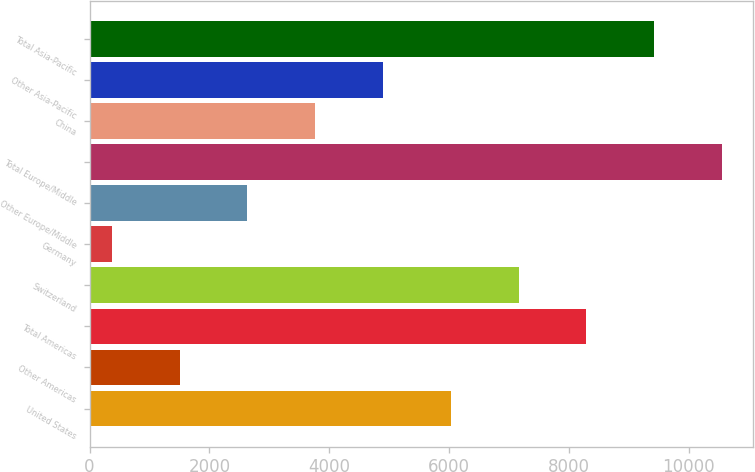Convert chart. <chart><loc_0><loc_0><loc_500><loc_500><bar_chart><fcel>United States<fcel>Other Americas<fcel>Total Americas<fcel>Switzerland<fcel>Germany<fcel>Other Europe/Middle<fcel>Total Europe/Middle<fcel>China<fcel>Other Asia-Pacific<fcel>Total Asia-Pacific<nl><fcel>6027<fcel>1503.8<fcel>8288.6<fcel>7157.8<fcel>373<fcel>2634.6<fcel>10550.2<fcel>3765.4<fcel>4896.2<fcel>9419.4<nl></chart> 